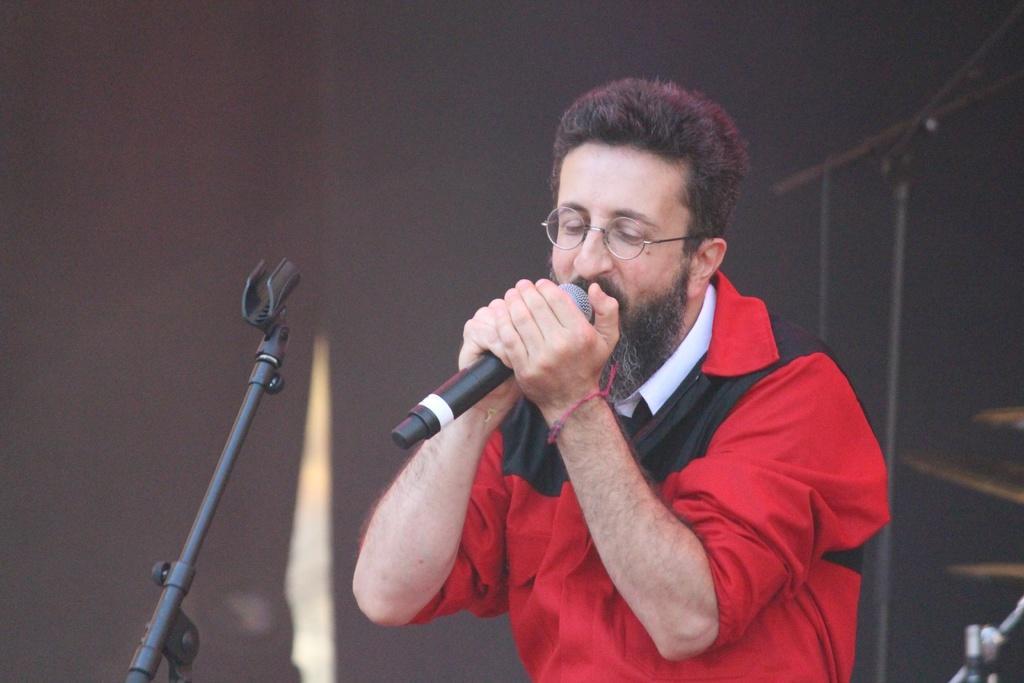Could you give a brief overview of what you see in this image? In this image there is a man who is wearing the red shirt is holding the mic near to his mouth. In front of him there is a mic stand. On the right side there are music plates and a mic stand. In the background there is a curtain. 